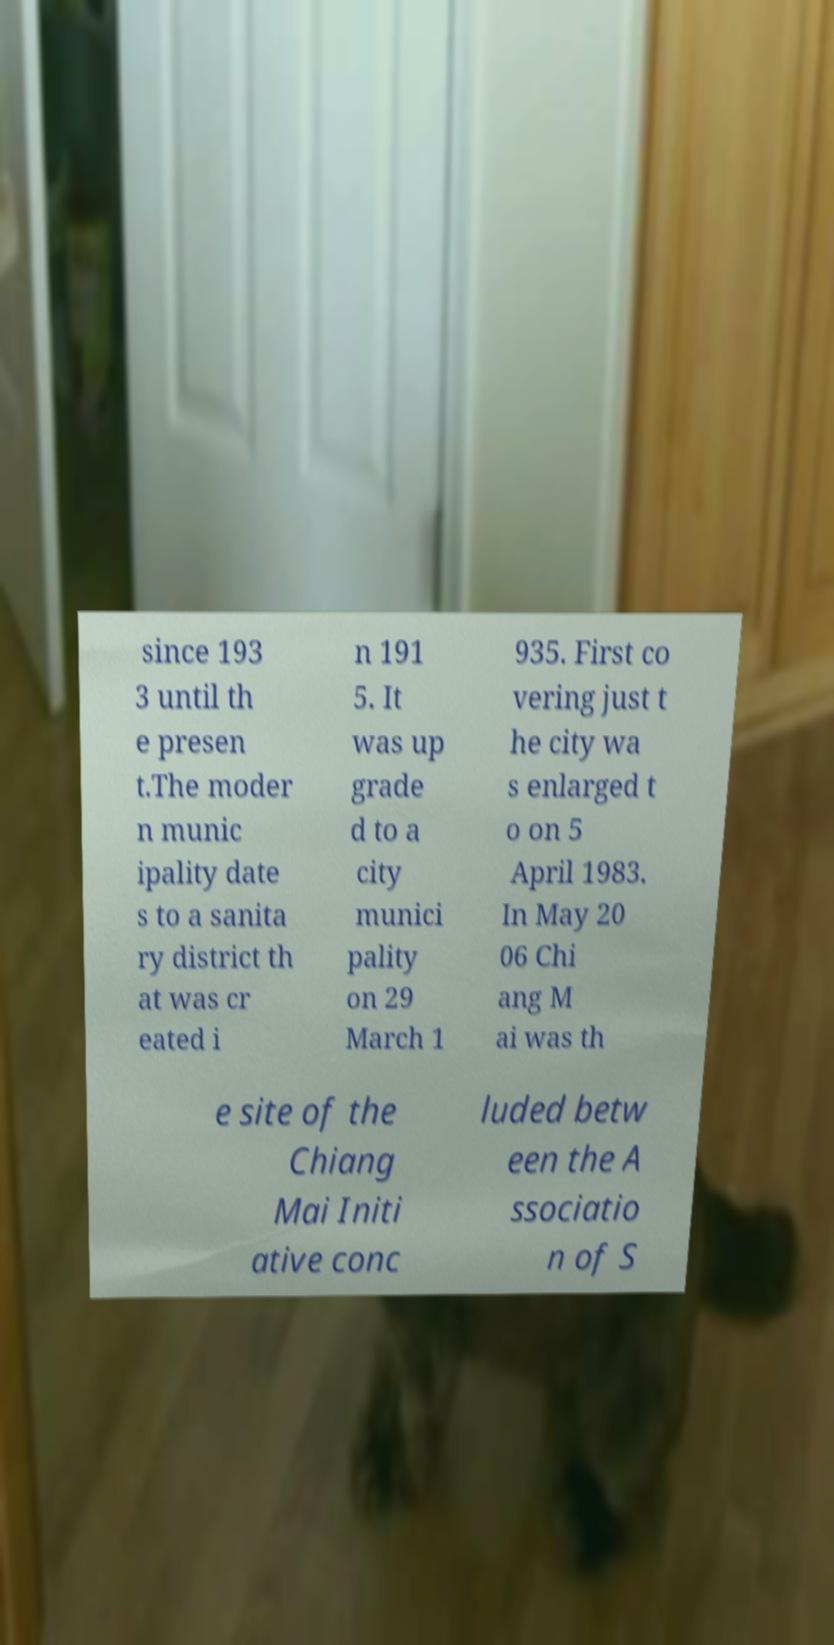Can you read and provide the text displayed in the image?This photo seems to have some interesting text. Can you extract and type it out for me? since 193 3 until th e presen t.The moder n munic ipality date s to a sanita ry district th at was cr eated i n 191 5. It was up grade d to a city munici pality on 29 March 1 935. First co vering just t he city wa s enlarged t o on 5 April 1983. In May 20 06 Chi ang M ai was th e site of the Chiang Mai Initi ative conc luded betw een the A ssociatio n of S 